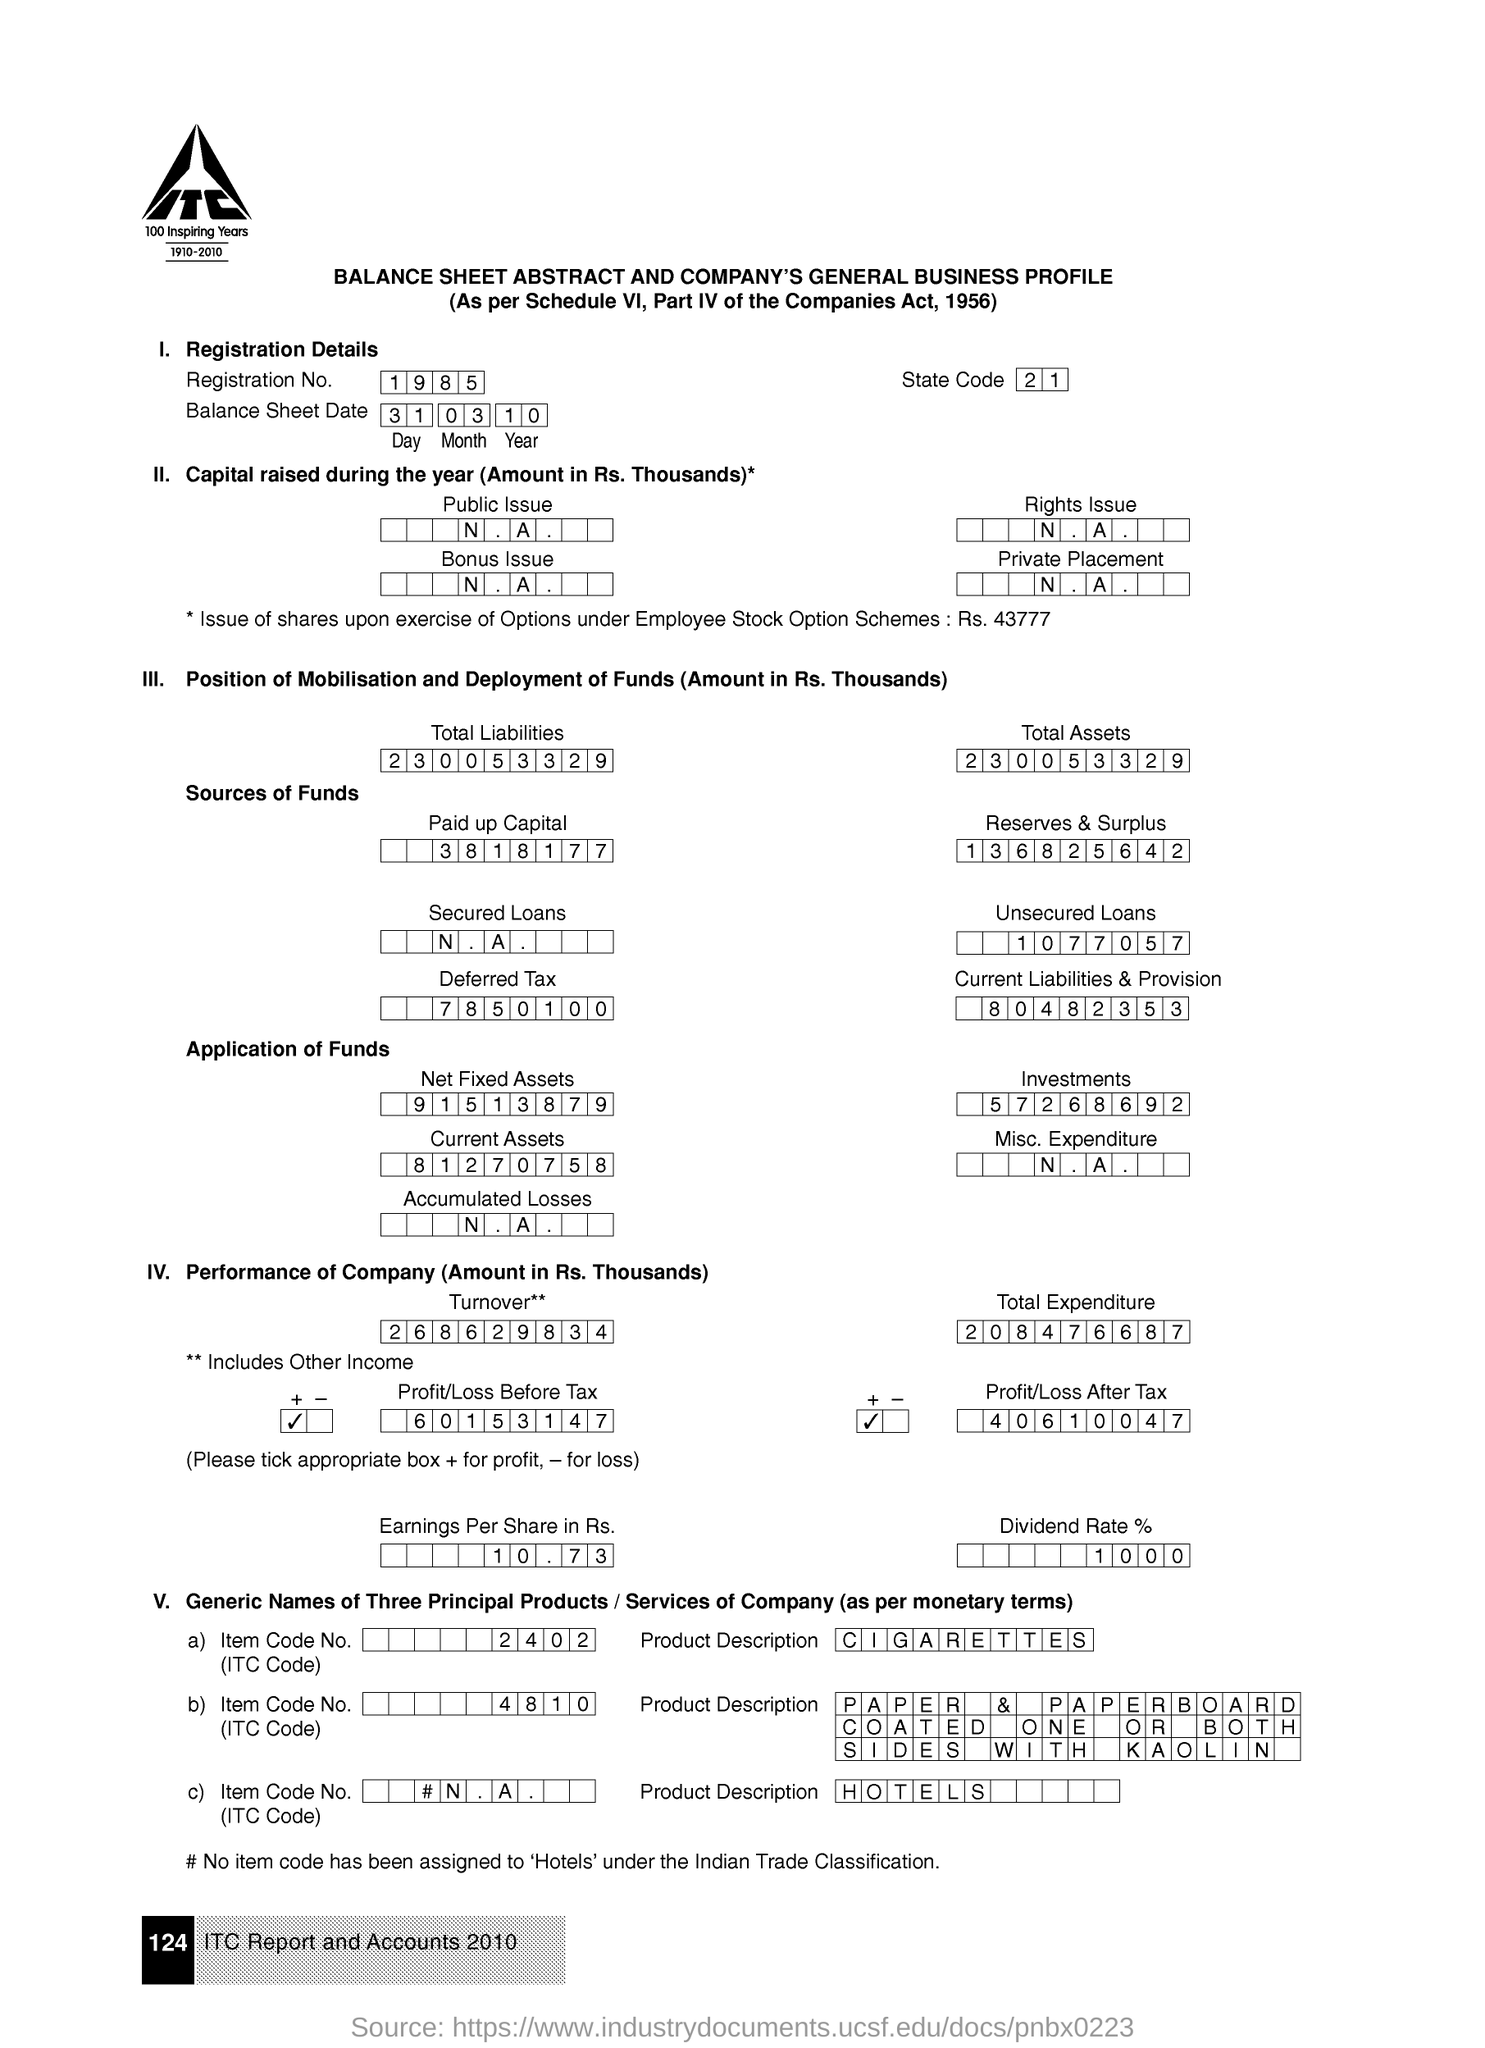Draw attention to some important aspects in this diagram. Please provide the state code as per the document, 21... 